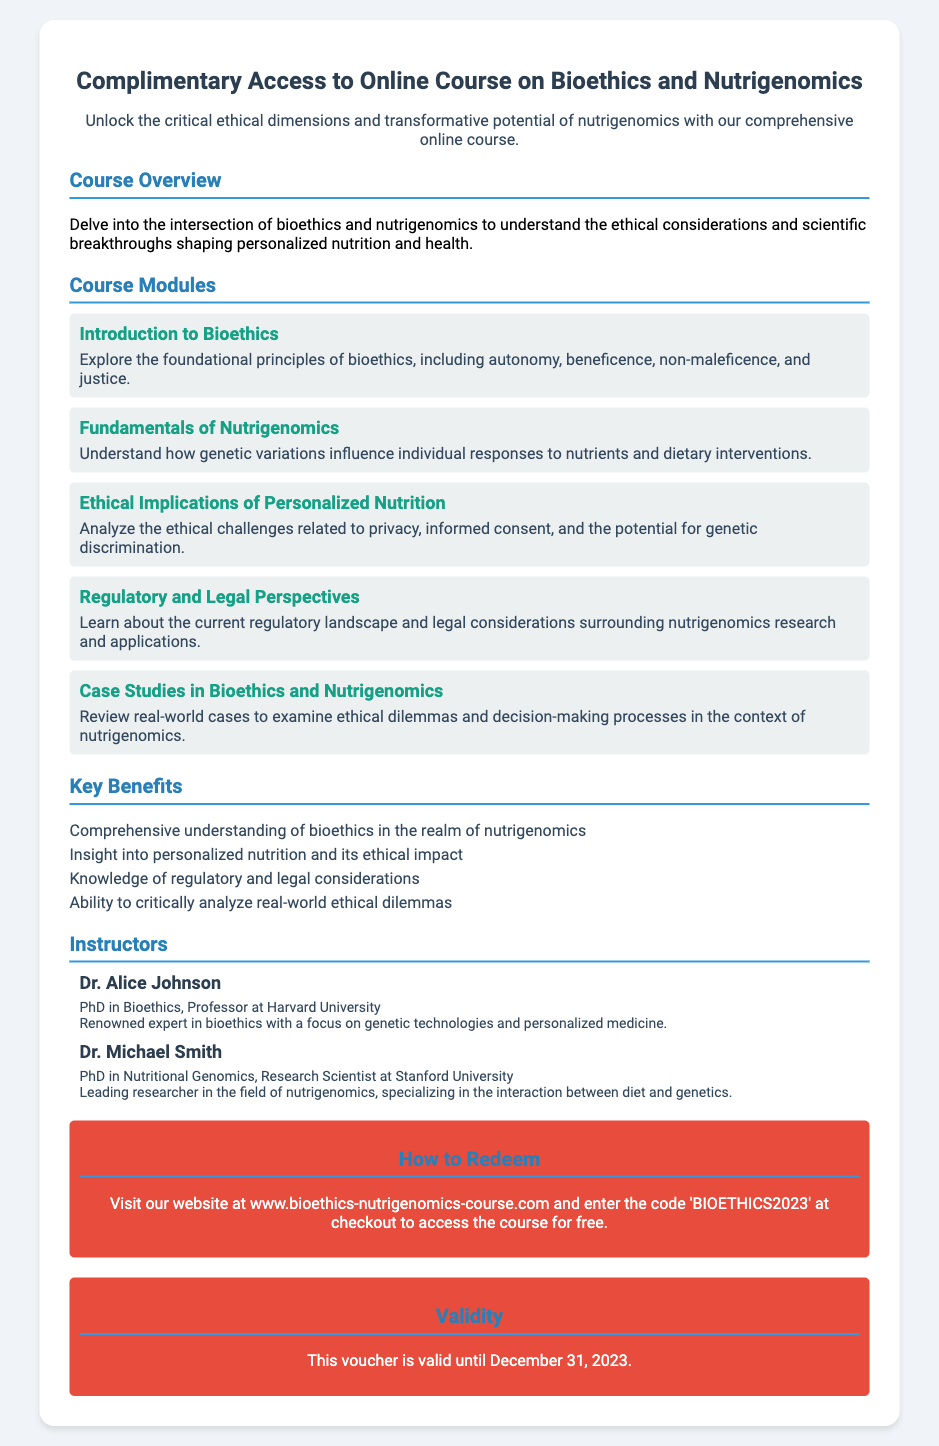What is the title of the course? The title of the course is clearly mentioned at the top of the document.
Answer: Complimentary Access to Online Course on Bioethics and Nutrigenomics Who is the first instructor? The document lists the instructors, with the first being mentioned in the "Instructors" section.
Answer: Dr. Alice Johnson What is the validity period of the voucher? The voucher's validity period is stated at the bottom of the document, specifying until when it can be used.
Answer: December 31, 2023 What is the code for redemption? The document provides a specific code to be used when redeeming the voucher for the course.
Answer: BIOETHICS2023 Which module covers regulatory aspects? The document outlines various modules, and one specifically addresses regulatory issues.
Answer: Regulatory and Legal Perspectives What is the main benefit of the course? The document lists multiple benefits, one of which captures the essence of the course's value.
Answer: Comprehensive understanding of bioethics in the realm of nutrigenomics How many modules are in the course? The number of course modules is indicated in the "Course Modules" section of the document.
Answer: Five What is the main focus of Dr. Michael Smith's research? The document summarizes the research interests of Dr. Michael Smith in the instructor's section.
Answer: Interaction between diet and genetics What type of course is described in the voucher? The voucher describes the nature of the course in the introductory sections.
Answer: Online Course 